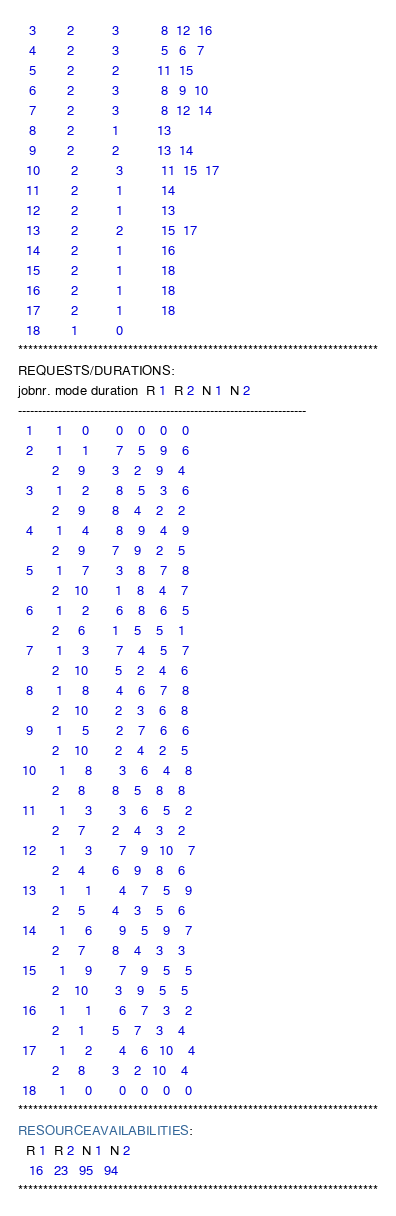<code> <loc_0><loc_0><loc_500><loc_500><_ObjectiveC_>   3        2          3           8  12  16
   4        2          3           5   6   7
   5        2          2          11  15
   6        2          3           8   9  10
   7        2          3           8  12  14
   8        2          1          13
   9        2          2          13  14
  10        2          3          11  15  17
  11        2          1          14
  12        2          1          13
  13        2          2          15  17
  14        2          1          16
  15        2          1          18
  16        2          1          18
  17        2          1          18
  18        1          0        
************************************************************************
REQUESTS/DURATIONS:
jobnr. mode duration  R 1  R 2  N 1  N 2
------------------------------------------------------------------------
  1      1     0       0    0    0    0
  2      1     1       7    5    9    6
         2     9       3    2    9    4
  3      1     2       8    5    3    6
         2     9       8    4    2    2
  4      1     4       8    9    4    9
         2     9       7    9    2    5
  5      1     7       3    8    7    8
         2    10       1    8    4    7
  6      1     2       6    8    6    5
         2     6       1    5    5    1
  7      1     3       7    4    5    7
         2    10       5    2    4    6
  8      1     8       4    6    7    8
         2    10       2    3    6    8
  9      1     5       2    7    6    6
         2    10       2    4    2    5
 10      1     8       3    6    4    8
         2     8       8    5    8    8
 11      1     3       3    6    5    2
         2     7       2    4    3    2
 12      1     3       7    9   10    7
         2     4       6    9    8    6
 13      1     1       4    7    5    9
         2     5       4    3    5    6
 14      1     6       9    5    9    7
         2     7       8    4    3    3
 15      1     9       7    9    5    5
         2    10       3    9    5    5
 16      1     1       6    7    3    2
         2     1       5    7    3    4
 17      1     2       4    6   10    4
         2     8       3    2   10    4
 18      1     0       0    0    0    0
************************************************************************
RESOURCEAVAILABILITIES:
  R 1  R 2  N 1  N 2
   16   23   95   94
************************************************************************
</code> 